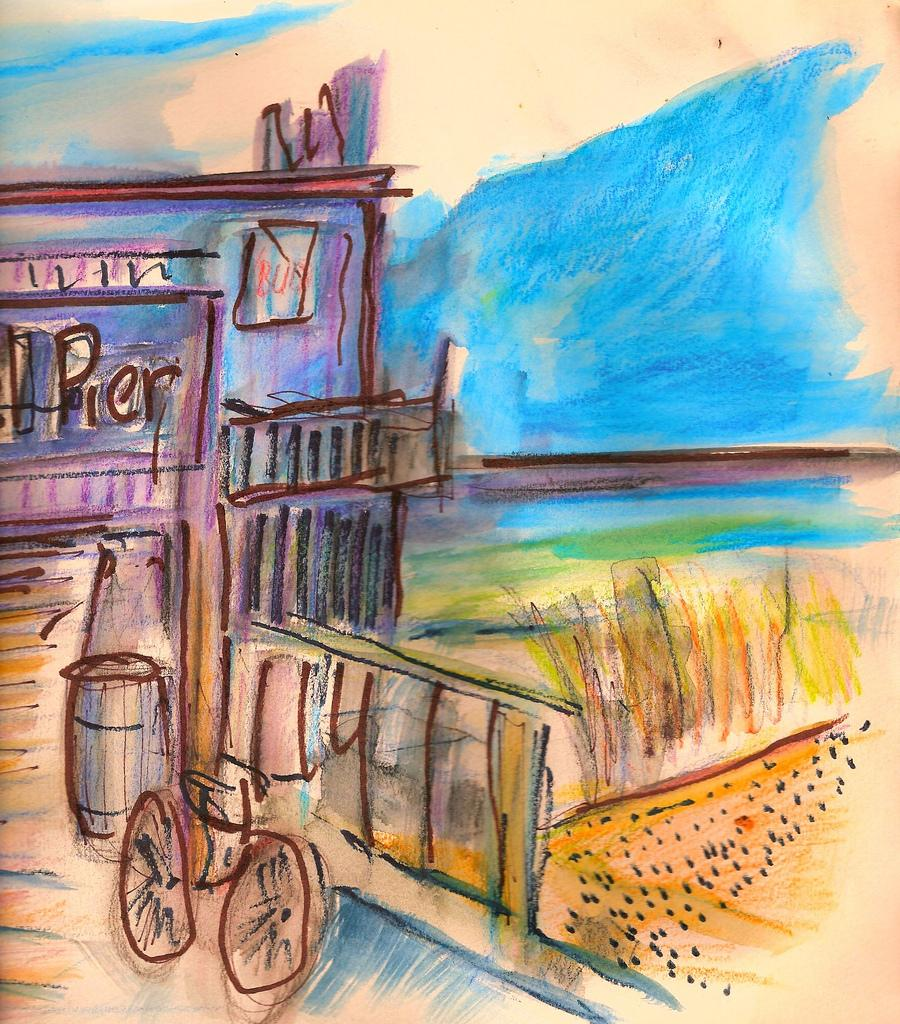What is depicted in the image? There is a drawing in the image. What type of vehicle is present in the drawing? There is a cycle in the drawing. What colors can be seen in the image? The colors pink, blue, and green are present in the image. Can you see a woolen sweater being knitted on the bridge in the image? There is no bridge or woolen sweater present in the image. 